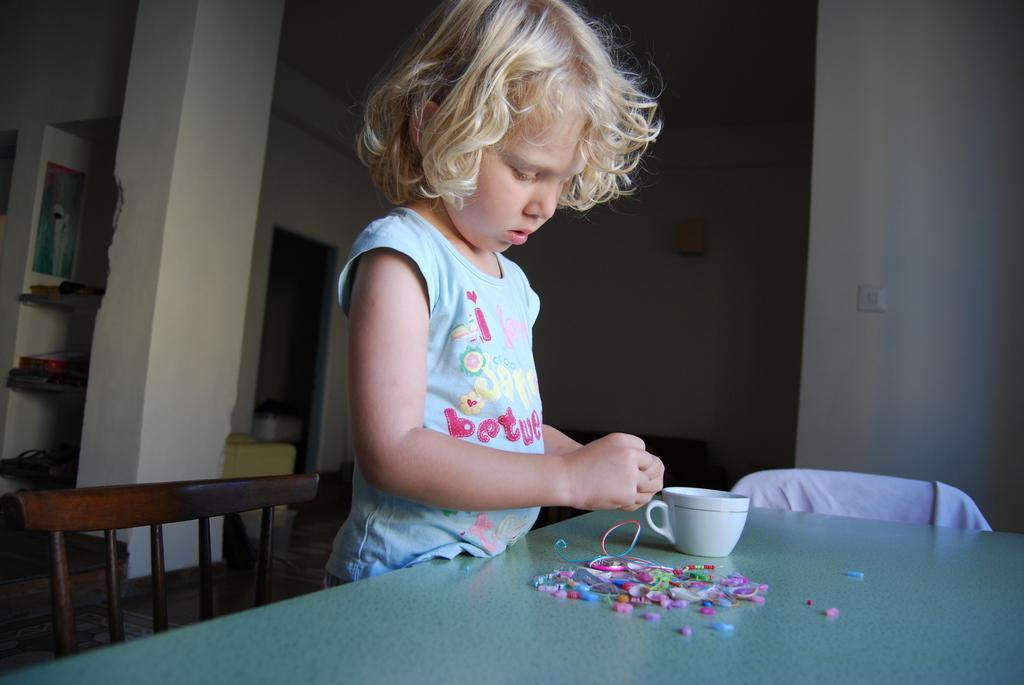How would you summarize this image in a sentence or two? This image is taken inside a room. In the middle of the image a kid is standing near the table and playing with few things. In the bottom of the image there is a table and a cup on it. In the right side of the image there is a n empty chair. In the background there is a wall with pillar. 